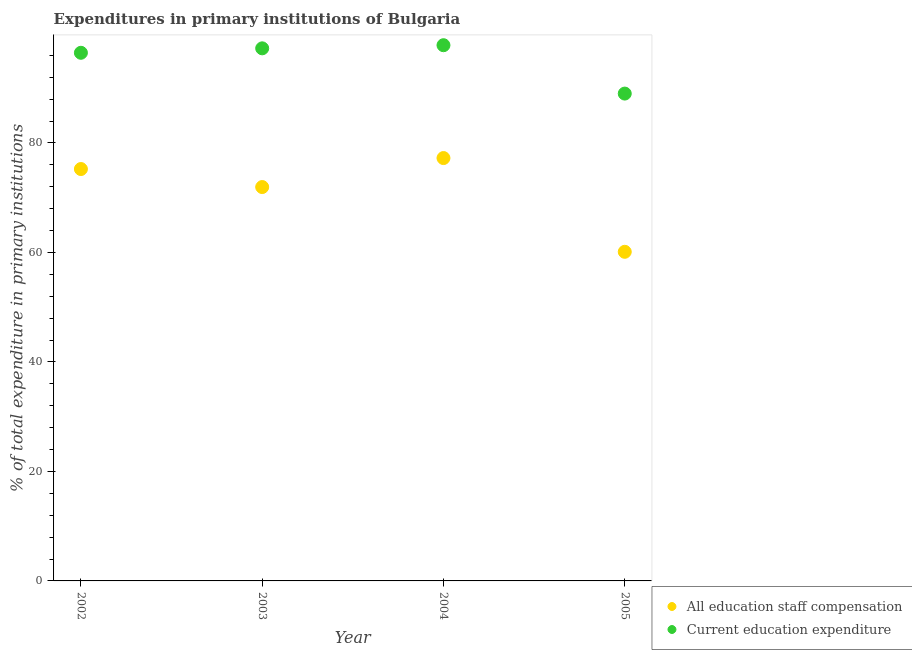Is the number of dotlines equal to the number of legend labels?
Provide a short and direct response. Yes. What is the expenditure in staff compensation in 2005?
Keep it short and to the point. 60.11. Across all years, what is the maximum expenditure in education?
Provide a short and direct response. 97.85. Across all years, what is the minimum expenditure in education?
Keep it short and to the point. 89.01. In which year was the expenditure in staff compensation maximum?
Provide a short and direct response. 2004. What is the total expenditure in education in the graph?
Keep it short and to the point. 380.61. What is the difference between the expenditure in education in 2002 and that in 2004?
Your response must be concise. -1.38. What is the difference between the expenditure in education in 2002 and the expenditure in staff compensation in 2005?
Make the answer very short. 36.35. What is the average expenditure in education per year?
Offer a very short reply. 95.15. In the year 2003, what is the difference between the expenditure in education and expenditure in staff compensation?
Keep it short and to the point. 25.34. What is the ratio of the expenditure in education in 2003 to that in 2005?
Offer a terse response. 1.09. Is the expenditure in staff compensation in 2003 less than that in 2005?
Ensure brevity in your answer.  No. Is the difference between the expenditure in education in 2002 and 2004 greater than the difference between the expenditure in staff compensation in 2002 and 2004?
Offer a very short reply. Yes. What is the difference between the highest and the second highest expenditure in staff compensation?
Keep it short and to the point. 2. What is the difference between the highest and the lowest expenditure in staff compensation?
Your answer should be very brief. 17.12. Is the sum of the expenditure in staff compensation in 2003 and 2004 greater than the maximum expenditure in education across all years?
Ensure brevity in your answer.  Yes. Does the expenditure in education monotonically increase over the years?
Provide a short and direct response. No. Is the expenditure in staff compensation strictly greater than the expenditure in education over the years?
Make the answer very short. No. Is the expenditure in staff compensation strictly less than the expenditure in education over the years?
Your response must be concise. Yes. How many dotlines are there?
Your answer should be compact. 2. How many years are there in the graph?
Your answer should be very brief. 4. What is the difference between two consecutive major ticks on the Y-axis?
Ensure brevity in your answer.  20. Are the values on the major ticks of Y-axis written in scientific E-notation?
Your answer should be very brief. No. Does the graph contain any zero values?
Provide a succinct answer. No. Where does the legend appear in the graph?
Provide a succinct answer. Bottom right. How are the legend labels stacked?
Give a very brief answer. Vertical. What is the title of the graph?
Your answer should be compact. Expenditures in primary institutions of Bulgaria. Does "Automatic Teller Machines" appear as one of the legend labels in the graph?
Make the answer very short. No. What is the label or title of the X-axis?
Your answer should be compact. Year. What is the label or title of the Y-axis?
Keep it short and to the point. % of total expenditure in primary institutions. What is the % of total expenditure in primary institutions of All education staff compensation in 2002?
Your answer should be compact. 75.23. What is the % of total expenditure in primary institutions of Current education expenditure in 2002?
Ensure brevity in your answer.  96.47. What is the % of total expenditure in primary institutions of All education staff compensation in 2003?
Your answer should be compact. 71.94. What is the % of total expenditure in primary institutions of Current education expenditure in 2003?
Your response must be concise. 97.28. What is the % of total expenditure in primary institutions in All education staff compensation in 2004?
Your response must be concise. 77.24. What is the % of total expenditure in primary institutions of Current education expenditure in 2004?
Provide a short and direct response. 97.85. What is the % of total expenditure in primary institutions in All education staff compensation in 2005?
Ensure brevity in your answer.  60.11. What is the % of total expenditure in primary institutions in Current education expenditure in 2005?
Your response must be concise. 89.01. Across all years, what is the maximum % of total expenditure in primary institutions in All education staff compensation?
Provide a succinct answer. 77.24. Across all years, what is the maximum % of total expenditure in primary institutions of Current education expenditure?
Provide a succinct answer. 97.85. Across all years, what is the minimum % of total expenditure in primary institutions in All education staff compensation?
Ensure brevity in your answer.  60.11. Across all years, what is the minimum % of total expenditure in primary institutions in Current education expenditure?
Provide a short and direct response. 89.01. What is the total % of total expenditure in primary institutions of All education staff compensation in the graph?
Give a very brief answer. 284.52. What is the total % of total expenditure in primary institutions of Current education expenditure in the graph?
Your answer should be compact. 380.61. What is the difference between the % of total expenditure in primary institutions in All education staff compensation in 2002 and that in 2003?
Give a very brief answer. 3.29. What is the difference between the % of total expenditure in primary institutions of Current education expenditure in 2002 and that in 2003?
Your answer should be compact. -0.81. What is the difference between the % of total expenditure in primary institutions in All education staff compensation in 2002 and that in 2004?
Offer a terse response. -2. What is the difference between the % of total expenditure in primary institutions in Current education expenditure in 2002 and that in 2004?
Offer a terse response. -1.38. What is the difference between the % of total expenditure in primary institutions in All education staff compensation in 2002 and that in 2005?
Make the answer very short. 15.12. What is the difference between the % of total expenditure in primary institutions in Current education expenditure in 2002 and that in 2005?
Keep it short and to the point. 7.45. What is the difference between the % of total expenditure in primary institutions in All education staff compensation in 2003 and that in 2004?
Ensure brevity in your answer.  -5.3. What is the difference between the % of total expenditure in primary institutions of Current education expenditure in 2003 and that in 2004?
Ensure brevity in your answer.  -0.57. What is the difference between the % of total expenditure in primary institutions of All education staff compensation in 2003 and that in 2005?
Your response must be concise. 11.83. What is the difference between the % of total expenditure in primary institutions of Current education expenditure in 2003 and that in 2005?
Ensure brevity in your answer.  8.26. What is the difference between the % of total expenditure in primary institutions of All education staff compensation in 2004 and that in 2005?
Offer a very short reply. 17.12. What is the difference between the % of total expenditure in primary institutions in Current education expenditure in 2004 and that in 2005?
Offer a terse response. 8.84. What is the difference between the % of total expenditure in primary institutions in All education staff compensation in 2002 and the % of total expenditure in primary institutions in Current education expenditure in 2003?
Give a very brief answer. -22.05. What is the difference between the % of total expenditure in primary institutions in All education staff compensation in 2002 and the % of total expenditure in primary institutions in Current education expenditure in 2004?
Offer a very short reply. -22.62. What is the difference between the % of total expenditure in primary institutions in All education staff compensation in 2002 and the % of total expenditure in primary institutions in Current education expenditure in 2005?
Keep it short and to the point. -13.78. What is the difference between the % of total expenditure in primary institutions in All education staff compensation in 2003 and the % of total expenditure in primary institutions in Current education expenditure in 2004?
Your answer should be compact. -25.91. What is the difference between the % of total expenditure in primary institutions in All education staff compensation in 2003 and the % of total expenditure in primary institutions in Current education expenditure in 2005?
Provide a short and direct response. -17.07. What is the difference between the % of total expenditure in primary institutions of All education staff compensation in 2004 and the % of total expenditure in primary institutions of Current education expenditure in 2005?
Your answer should be very brief. -11.78. What is the average % of total expenditure in primary institutions in All education staff compensation per year?
Your answer should be compact. 71.13. What is the average % of total expenditure in primary institutions of Current education expenditure per year?
Offer a terse response. 95.15. In the year 2002, what is the difference between the % of total expenditure in primary institutions of All education staff compensation and % of total expenditure in primary institutions of Current education expenditure?
Your response must be concise. -21.23. In the year 2003, what is the difference between the % of total expenditure in primary institutions in All education staff compensation and % of total expenditure in primary institutions in Current education expenditure?
Provide a succinct answer. -25.34. In the year 2004, what is the difference between the % of total expenditure in primary institutions in All education staff compensation and % of total expenditure in primary institutions in Current education expenditure?
Ensure brevity in your answer.  -20.61. In the year 2005, what is the difference between the % of total expenditure in primary institutions in All education staff compensation and % of total expenditure in primary institutions in Current education expenditure?
Your response must be concise. -28.9. What is the ratio of the % of total expenditure in primary institutions of All education staff compensation in 2002 to that in 2003?
Your response must be concise. 1.05. What is the ratio of the % of total expenditure in primary institutions in Current education expenditure in 2002 to that in 2003?
Your answer should be very brief. 0.99. What is the ratio of the % of total expenditure in primary institutions of All education staff compensation in 2002 to that in 2004?
Your answer should be very brief. 0.97. What is the ratio of the % of total expenditure in primary institutions of Current education expenditure in 2002 to that in 2004?
Offer a terse response. 0.99. What is the ratio of the % of total expenditure in primary institutions in All education staff compensation in 2002 to that in 2005?
Give a very brief answer. 1.25. What is the ratio of the % of total expenditure in primary institutions in Current education expenditure in 2002 to that in 2005?
Give a very brief answer. 1.08. What is the ratio of the % of total expenditure in primary institutions of All education staff compensation in 2003 to that in 2004?
Make the answer very short. 0.93. What is the ratio of the % of total expenditure in primary institutions of Current education expenditure in 2003 to that in 2004?
Offer a terse response. 0.99. What is the ratio of the % of total expenditure in primary institutions of All education staff compensation in 2003 to that in 2005?
Make the answer very short. 1.2. What is the ratio of the % of total expenditure in primary institutions of Current education expenditure in 2003 to that in 2005?
Your answer should be compact. 1.09. What is the ratio of the % of total expenditure in primary institutions in All education staff compensation in 2004 to that in 2005?
Provide a succinct answer. 1.28. What is the ratio of the % of total expenditure in primary institutions of Current education expenditure in 2004 to that in 2005?
Provide a succinct answer. 1.1. What is the difference between the highest and the second highest % of total expenditure in primary institutions in All education staff compensation?
Give a very brief answer. 2. What is the difference between the highest and the lowest % of total expenditure in primary institutions in All education staff compensation?
Provide a short and direct response. 17.12. What is the difference between the highest and the lowest % of total expenditure in primary institutions of Current education expenditure?
Offer a very short reply. 8.84. 